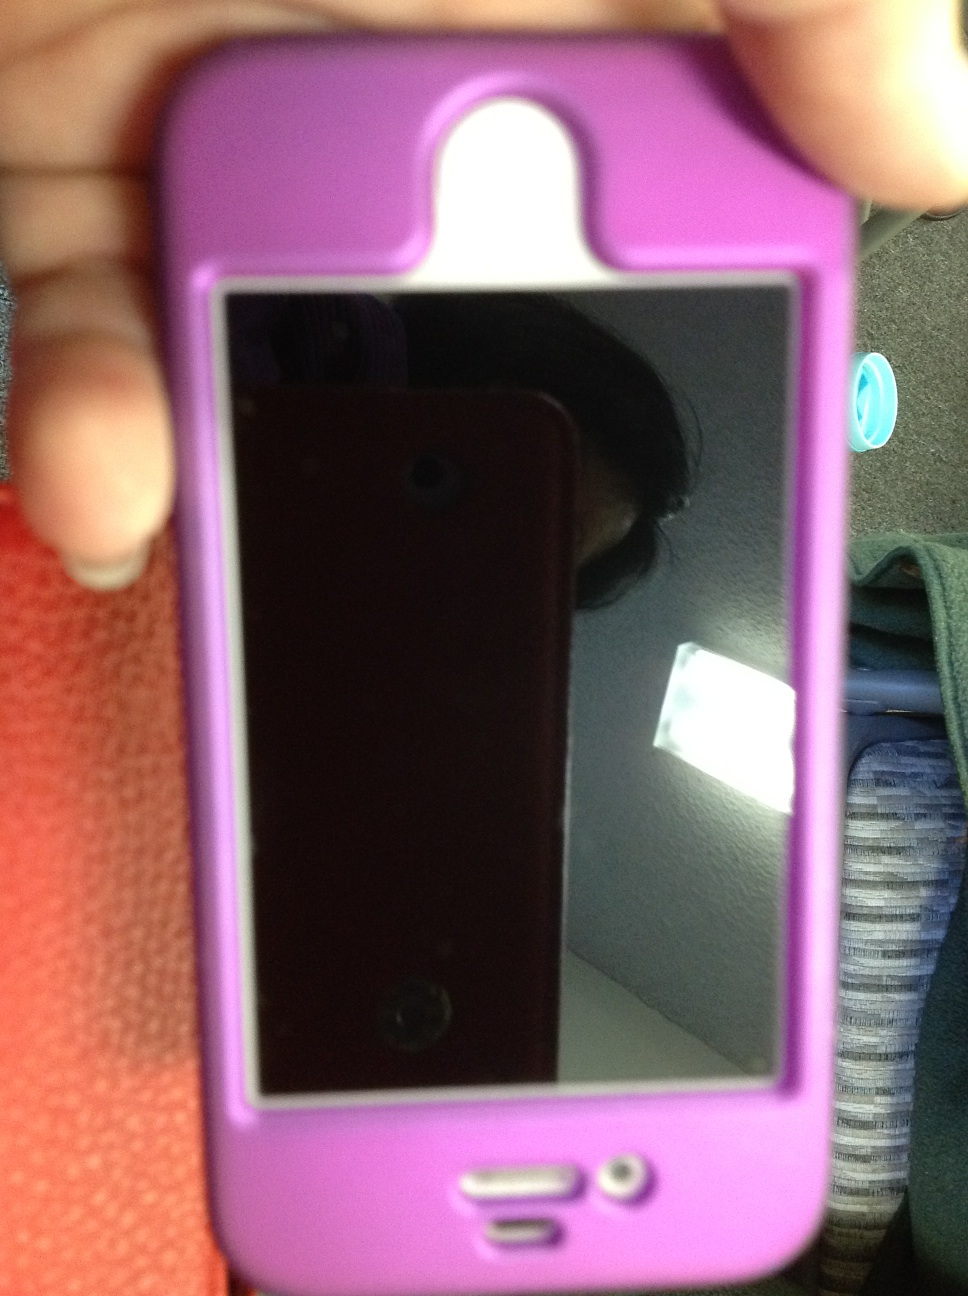Imagine this phone could talk. What would it say? Hello! I'm your loyal iPhone, neatly wrapped in my stylish pink case. I've shared countless moments with you, through laughter and late-night conversations. I've helped you stay connected with your loved ones, guided you on your travels, and even entertained you with games and movies. While I may have faced a few drops and dings along the way, my protective case has kept me safe and sound. I'm more than just a gadget—I'm a part of your daily life and memories. What adventures have we been on together? We've embarked on countless adventures together! From capturing the beautiful sunsets on sandy beaches to navigating bustling city streets. Remember that time we climbed up the hills for that spectacular view? Or those cozy nights where we binge-watched our favorite series together? We've explored new places, tasted new cuisines, and even got lost but found our way back with the help of my GPS. Every notification, every call, every message has added a page to our shared story. What are the specs of this iPhone model? Based on the design and features visible in the image, it appears to be an older iPhone model, potentially around the iPhone 4 or 5 series. These models typically come with a Retina display, an 8-megapixel rear camera, a front-facing camera for video calls, and a home button. They also feature Apple's A5 or A6 processor and typically offer storage capacities ranging from 8GB to 64GB. Please note that exact specs would depend on the specific model and configuration. 